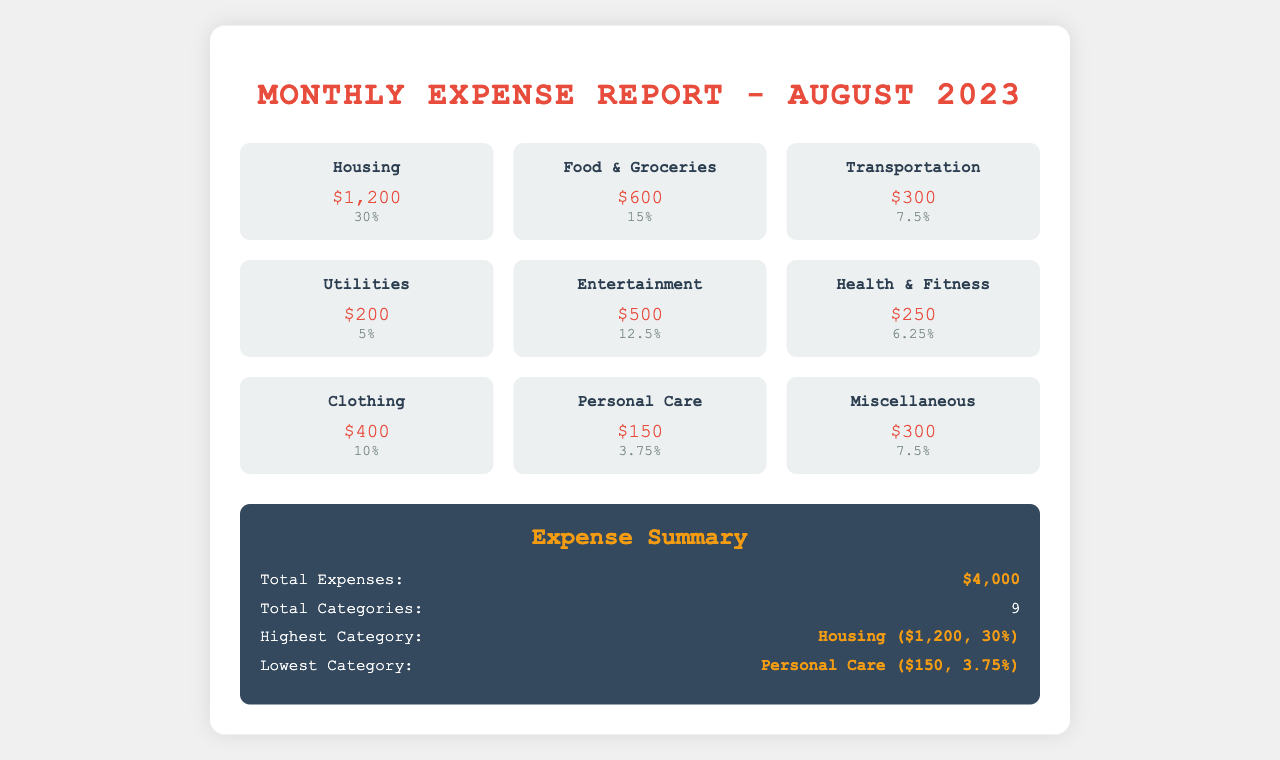What is the total amount for Housing? The total amount for Housing is detailed in the document as $1,200.
Answer: $1,200 What percentage of the total expenses is spent on Food & Groceries? The document states that Food & Groceries accounts for 15% of the total expenses.
Answer: 15% What is the highest spending category? The highest spending category is given as Housing, which amounts to $1,200 or 30%.
Answer: Housing ($1,200, 30%) How much is allocated to Personal Care? The document specifies that Personal Care expenses amount to $150.
Answer: $150 What is the total amount of expenses for August 2023? The total amount of expenses is summarized in the report as $4,000.
Answer: $4,000 How many categories of expenses are listed? The document lists a total of 9 expense categories.
Answer: 9 Which category has the lowest spending? According to the document, the category with the lowest spending is Personal Care.
Answer: Personal Care What is the percentage spent on Transportation? The document indicates that 7.5% of the total expenses are allocated to Transportation.
Answer: 7.5% 